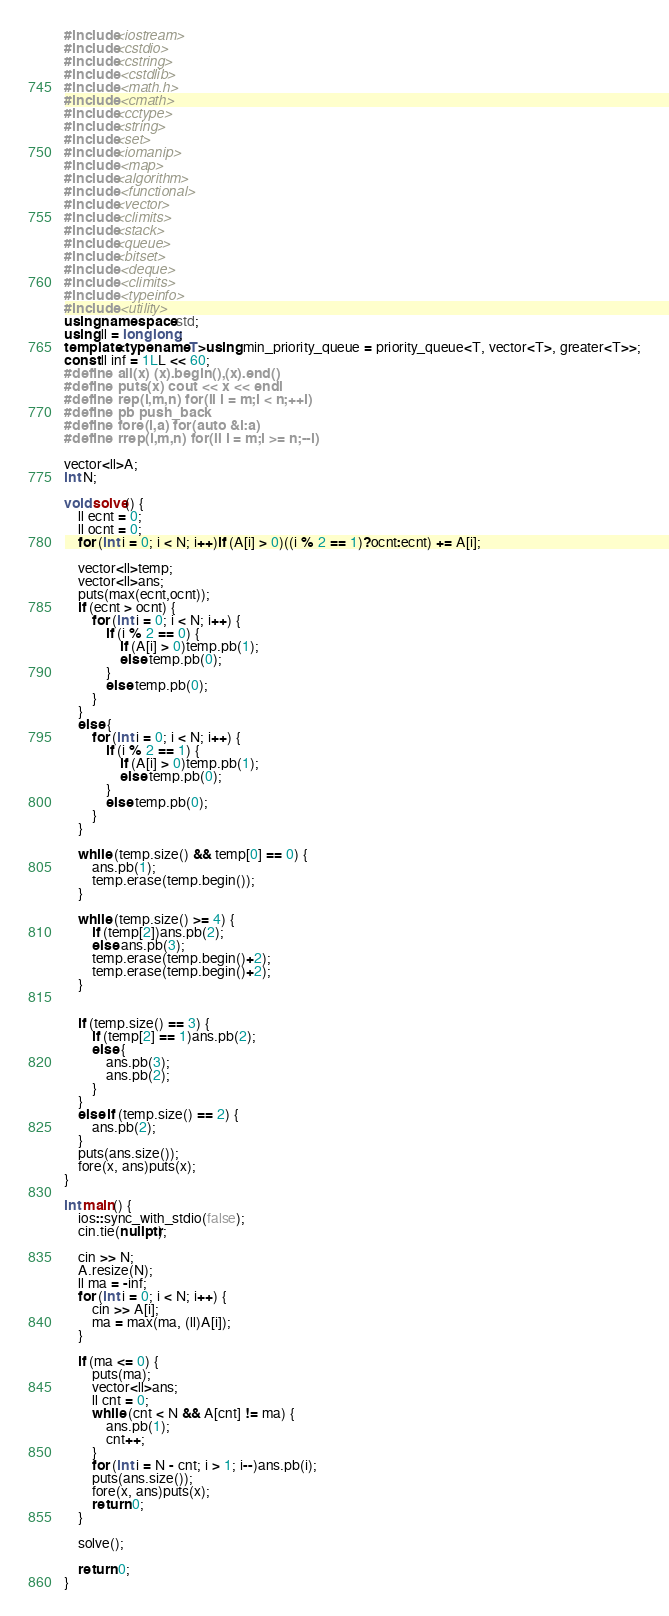Convert code to text. <code><loc_0><loc_0><loc_500><loc_500><_C++_>#include<iostream>
#include<cstdio>
#include<cstring>
#include <cstdlib>  
#include <math.h>
#include <cmath>
#include<cctype>
#include<string>
#include<set>
#include<iomanip>
#include <map>
#include<algorithm>
#include <functional>
#include<vector>
#include<climits>
#include<stack>
#include<queue>
#include<bitset>
#include <deque>
#include <climits>
#include <typeinfo>
#include <utility> 
using namespace std;
using ll = long long;
template<typename T>using min_priority_queue = priority_queue<T, vector<T>, greater<T>>;
const ll inf = 1LL << 60;
#define all(x) (x).begin(),(x).end()
#define puts(x) cout << x << endl
#define rep(i,m,n) for(ll i = m;i < n;++i)
#define pb push_back
#define fore(i,a) for(auto &i:a)
#define rrep(i,m,n) for(ll i = m;i >= n;--i)

vector<ll>A;
int N;

void solve() {
	ll ecnt = 0;
	ll ocnt = 0;
	for (int i = 0; i < N; i++)if (A[i] > 0)((i % 2 == 1)?ocnt:ecnt) += A[i];

	vector<ll>temp;
	vector<ll>ans;
	puts(max(ecnt,ocnt));
	if (ecnt > ocnt) {
		for (int i = 0; i < N; i++) {
			if (i % 2 == 0) {
				if (A[i] > 0)temp.pb(1);
				else temp.pb(0);
			}
			else temp.pb(0);
		}
	}
	else {
		for (int i = 0; i < N; i++) {
			if (i % 2 == 1) {
				if (A[i] > 0)temp.pb(1);
				else temp.pb(0);
			}
			else temp.pb(0);
		}
	}

	while (temp.size() && temp[0] == 0) {
		ans.pb(1);
		temp.erase(temp.begin());
	}

	while (temp.size() >= 4) {
		if (temp[2])ans.pb(2);
		else ans.pb(3);
		temp.erase(temp.begin()+2);
		temp.erase(temp.begin()+2);
	}


	if (temp.size() == 3) {
		if (temp[2] == 1)ans.pb(2);
		else {
			ans.pb(3);
			ans.pb(2);
		}
	}
	else if (temp.size() == 2) {
		ans.pb(2);
	}
	puts(ans.size());
	fore(x, ans)puts(x);
}

int main() {
	ios::sync_with_stdio(false);
	cin.tie(nullptr);

	cin >> N;
	A.resize(N);
	ll ma = -inf;
	for (int i = 0; i < N; i++) {
		cin >> A[i];
		ma = max(ma, (ll)A[i]);
	}

	if (ma <= 0) {
		puts(ma);
		vector<ll>ans;
		ll cnt = 0;
		while (cnt < N && A[cnt] != ma) {
			ans.pb(1);
			cnt++;
		}
		for (int i = N - cnt; i > 1; i--)ans.pb(i);
		puts(ans.size());
		fore(x, ans)puts(x);
		return 0;
	}

	solve();
	
	return 0;
}</code> 